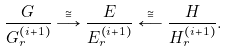Convert formula to latex. <formula><loc_0><loc_0><loc_500><loc_500>\frac { G } { G _ { r } ^ { \left ( i + 1 \right ) } } \overset { \cong } { \longrightarrow } \frac { E } { E _ { r } ^ { \left ( i + 1 \right ) } } \overset { \cong } { \longleftarrow } \frac { H } { H _ { r } ^ { \left ( i + 1 \right ) } } .</formula> 